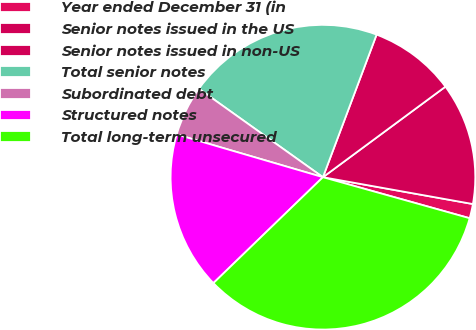Convert chart. <chart><loc_0><loc_0><loc_500><loc_500><pie_chart><fcel>Year ended December 31 (in<fcel>Senior notes issued in the US<fcel>Senior notes issued in non-US<fcel>Total senior notes<fcel>Subordinated debt<fcel>Structured notes<fcel>Total long-term unsecured<nl><fcel>1.52%<fcel>12.95%<fcel>9.14%<fcel>20.87%<fcel>5.33%<fcel>16.76%<fcel>33.43%<nl></chart> 